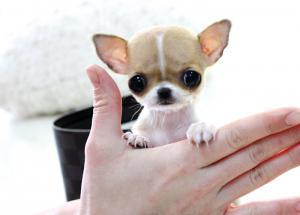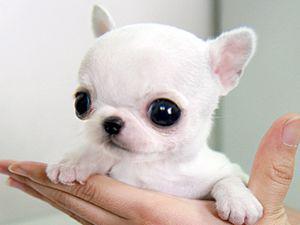The first image is the image on the left, the second image is the image on the right. Considering the images on both sides, is "Both images show one small dog in a person's hand" valid? Answer yes or no. Yes. The first image is the image on the left, the second image is the image on the right. Considering the images on both sides, is "Each image shows one teacup puppy displayed on a human hand, and the puppy on the right is solid white." valid? Answer yes or no. Yes. 